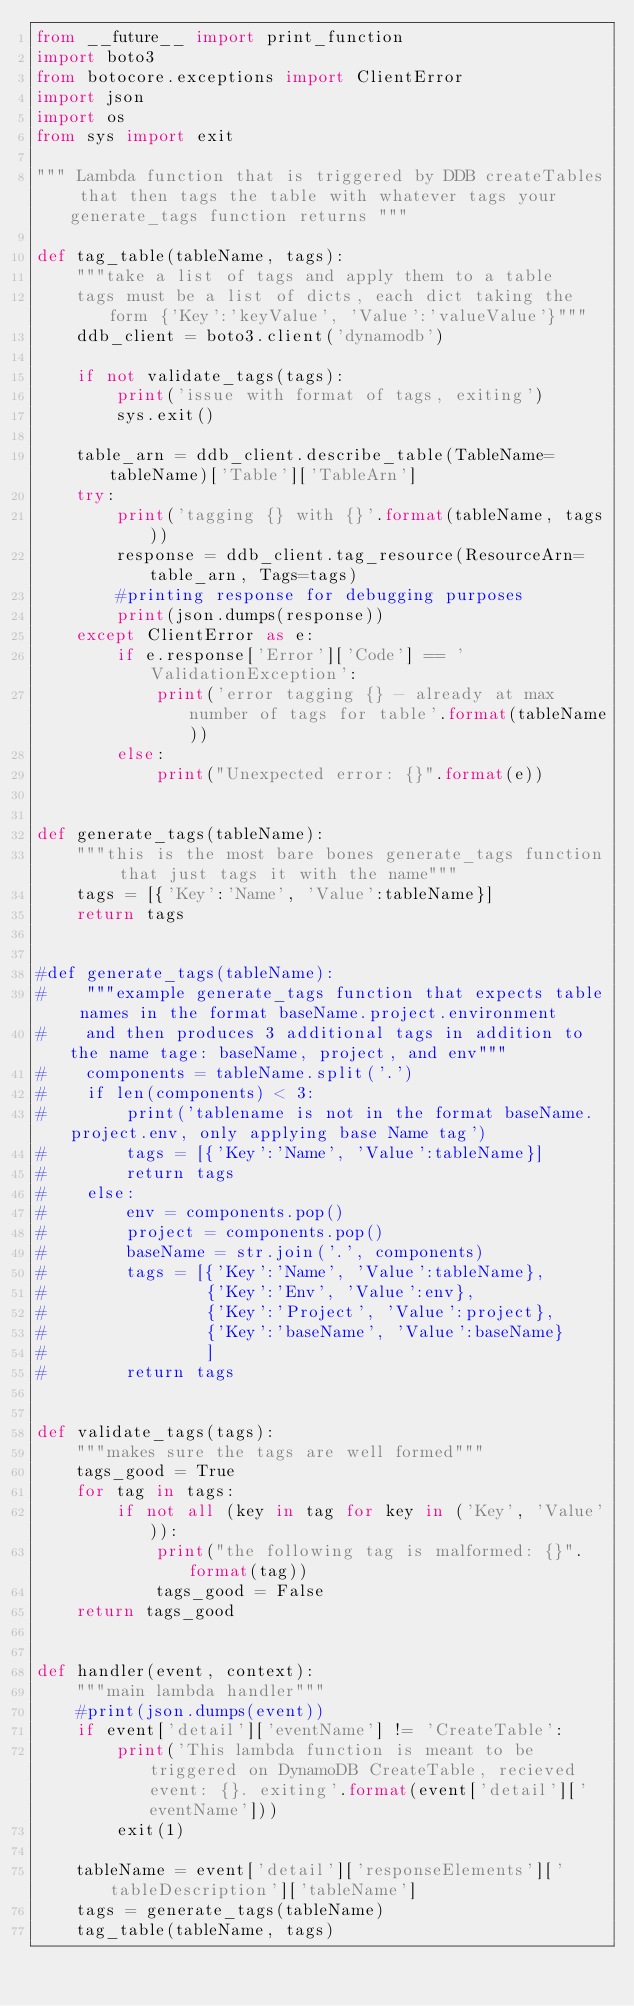Convert code to text. <code><loc_0><loc_0><loc_500><loc_500><_Python_>from __future__ import print_function
import boto3
from botocore.exceptions import ClientError
import json
import os
from sys import exit

""" Lambda function that is triggered by DDB createTables that then tags the table with whatever tags your generate_tags function returns """

def tag_table(tableName, tags):
    """take a list of tags and apply them to a table 
    tags must be a list of dicts, each dict taking the form {'Key':'keyValue', 'Value':'valueValue'}"""
    ddb_client = boto3.client('dynamodb')
    
    if not validate_tags(tags):
        print('issue with format of tags, exiting')
        sys.exit()
        
    table_arn = ddb_client.describe_table(TableName=tableName)['Table']['TableArn']
    try:
        print('tagging {} with {}'.format(tableName, tags))
        response = ddb_client.tag_resource(ResourceArn=table_arn, Tags=tags)
        #printing response for debugging purposes
        print(json.dumps(response))
    except ClientError as e:
        if e.response['Error']['Code'] == 'ValidationException':
            print('error tagging {} - already at max number of tags for table'.format(tableName))
        else:
            print("Unexpected error: {}".format(e))


def generate_tags(tableName):
    """this is the most bare bones generate_tags function that just tags it with the name"""
    tags = [{'Key':'Name', 'Value':tableName}]
    return tags


#def generate_tags(tableName):
#    """example generate_tags function that expects table names in the format baseName.project.environment
#    and then produces 3 additional tags in addition to the name tage: baseName, project, and env"""
#    components = tableName.split('.')
#    if len(components) < 3:
#        print('tablename is not in the format baseName.project.env, only applying base Name tag')
#        tags = [{'Key':'Name', 'Value':tableName}]
#        return tags
#    else:
#        env = components.pop()
#        project = components.pop()
#        baseName = str.join('.', components)
#        tags = [{'Key':'Name', 'Value':tableName}, 
#                {'Key':'Env', 'Value':env},
#                {'Key':'Project', 'Value':project},
#                {'Key':'baseName', 'Value':baseName}
#                ]
#        return tags


def validate_tags(tags):
    """makes sure the tags are well formed"""
    tags_good = True
    for tag in tags:
        if not all (key in tag for key in ('Key', 'Value')):
            print("the following tag is malformed: {}".format(tag))
            tags_good = False
    return tags_good


def handler(event, context):
    """main lambda handler"""
    #print(json.dumps(event))
    if event['detail']['eventName'] != 'CreateTable':
        print('This lambda function is meant to be triggered on DynamoDB CreateTable, recieved event: {}. exiting'.format(event['detail']['eventName']))
        exit(1)

    tableName = event['detail']['responseElements']['tableDescription']['tableName']
    tags = generate_tags(tableName)
    tag_table(tableName, tags)



</code> 